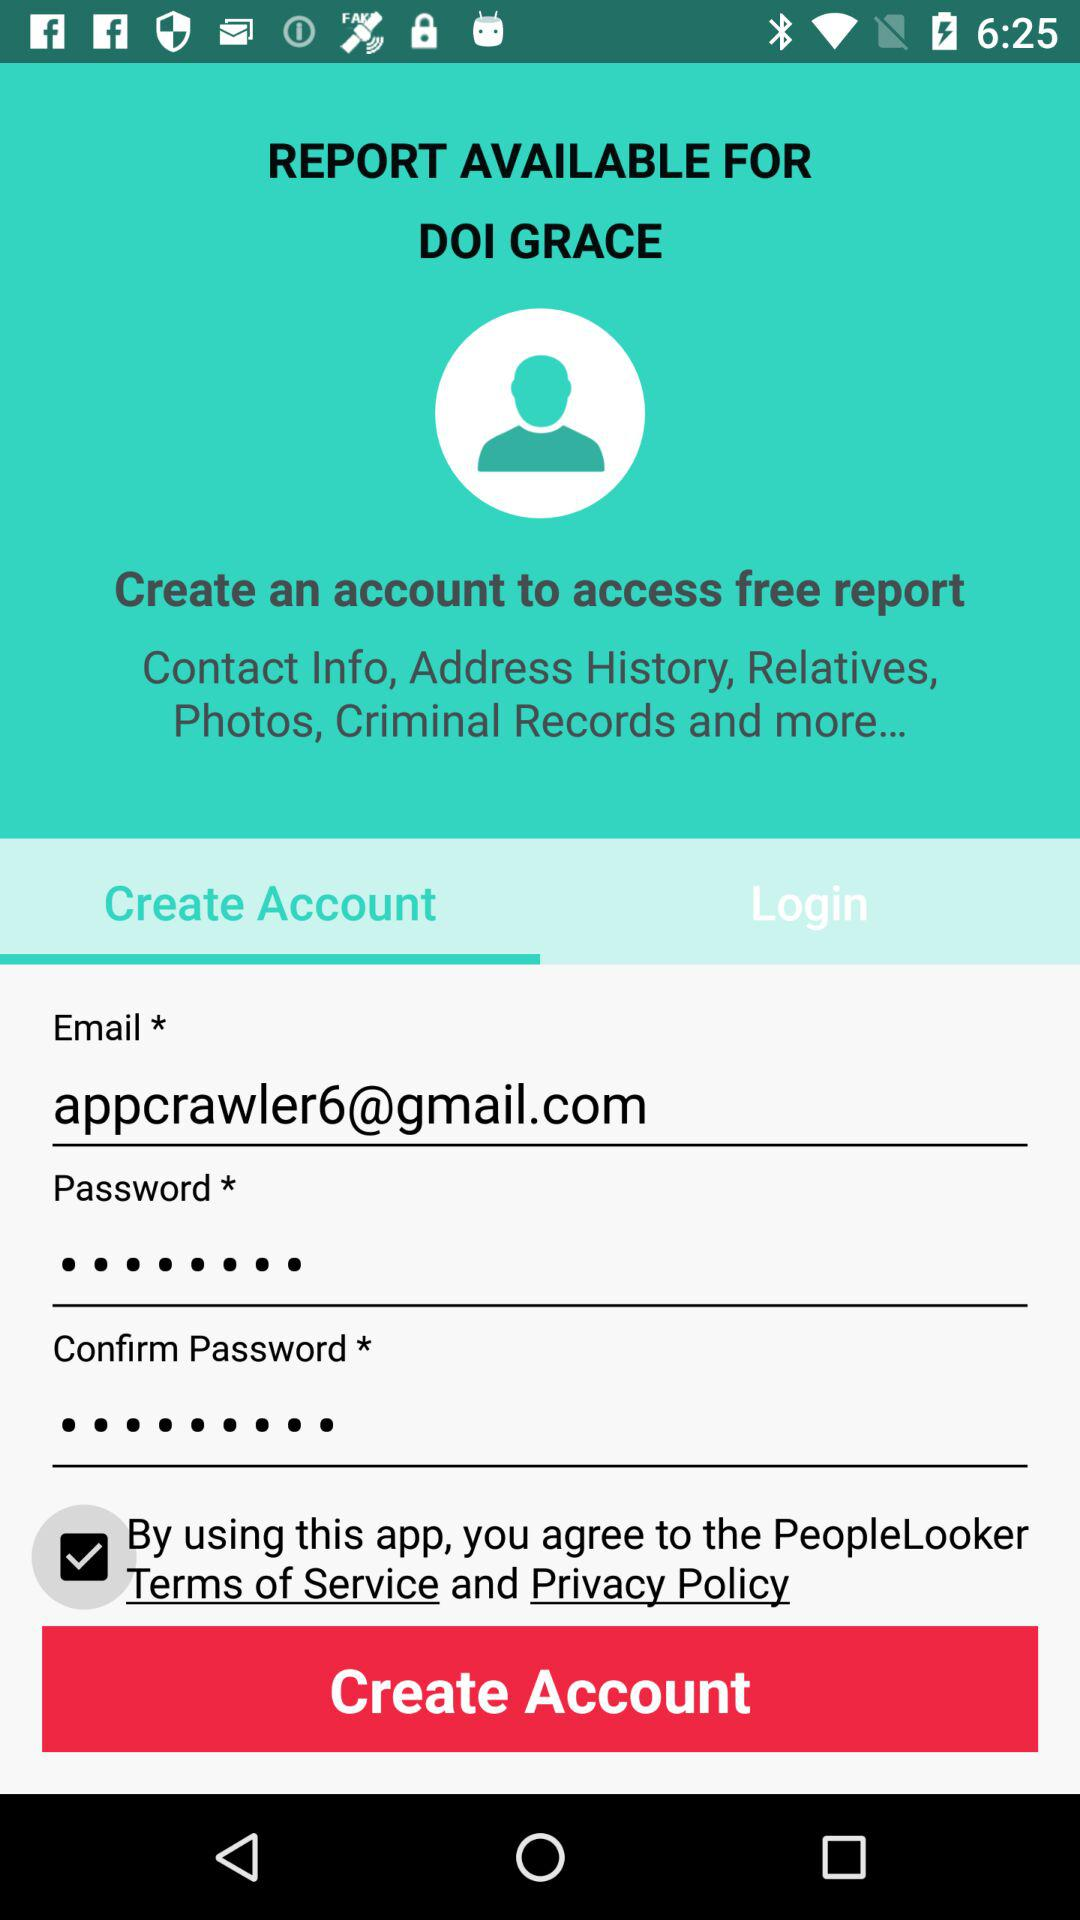How many text inputs are there for the user to create an account?
Answer the question using a single word or phrase. 3 